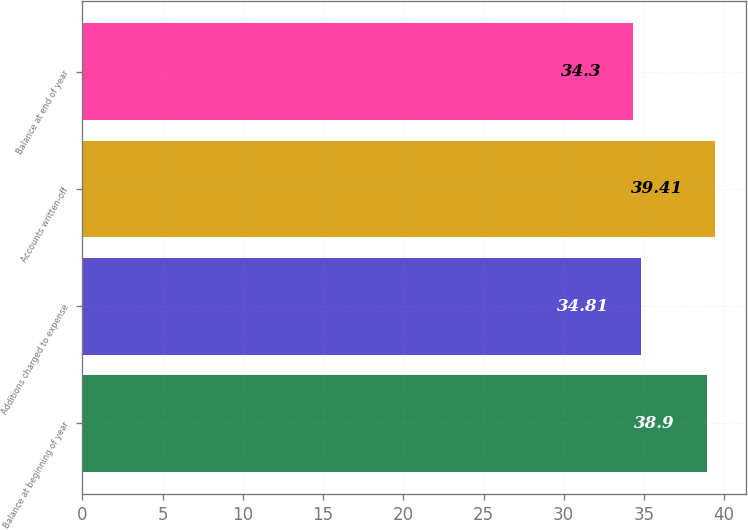Convert chart to OTSL. <chart><loc_0><loc_0><loc_500><loc_500><bar_chart><fcel>Balance at beginning of year<fcel>Additions charged to expense<fcel>Accounts written-off<fcel>Balance at end of year<nl><fcel>38.9<fcel>34.81<fcel>39.41<fcel>34.3<nl></chart> 